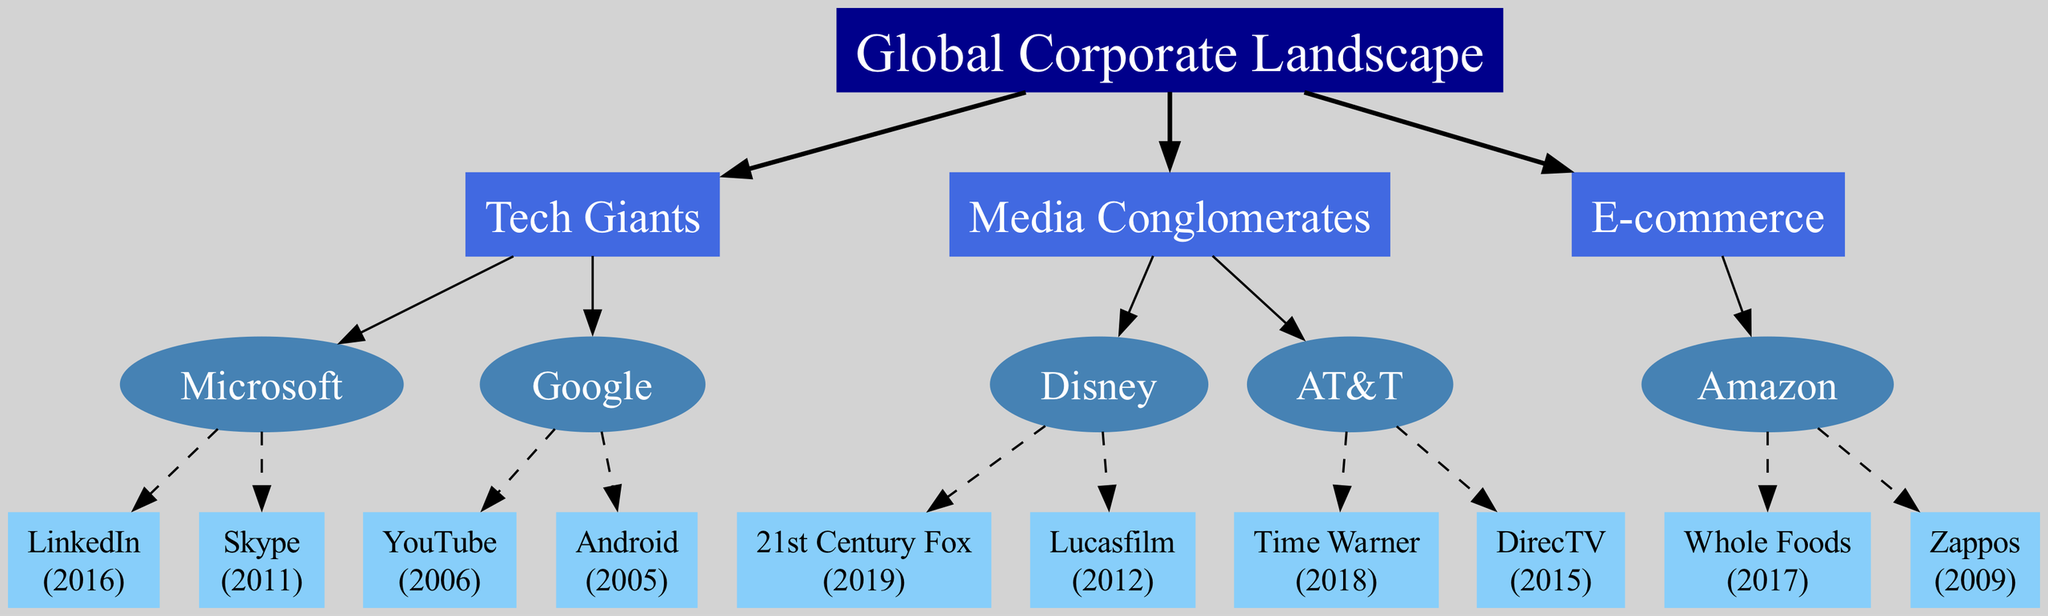What is the root of the family tree? The root of the family tree is the starting point, which denotes the overall theme of the diagram. Based on the data provided, it identifies the broad category encapsulating all companies and their acquisitions. Therefore, the root is "Global Corporate Landscape."
Answer: Global Corporate Landscape How many branches are there in the family tree? The branches of the family tree represent the major categories of companies involved in mergers and acquisitions. Counting the distinct branches listed in the data shows there are three branches: Tech Giants, Media Conglomerates, and E-commerce.
Answer: 3 Which company acquired LinkedIn? To find the company that acquired LinkedIn, we examine the acquisitions listed under the "Tech Giants" branch. LinkedIn is specifically noted as an acquisition of Microsoft in 2016.
Answer: Microsoft How many acquisitions did Disney make? This requires identifying the total number of acquisitions listed under Disney in the diagram. The data indicates that Disney has made two acquisitions: 21st Century Fox (2019) and Lucasfilm (2012). Therefore, the count of acquisitions is two.
Answer: 2 Which company has the latest acquisition, and what is it? To answer this, we evaluate the years of acquisitions within the diagram across all companies. The most recent acquisition listed is by Disney, which acquired 21st Century Fox in 2019.
Answer: Disney, 21st Century Fox What is the relationship between Google and Android? The relationship can be understood by examining the paths in the family tree structure. Google is a parent company under the "Tech Giants" branch, and Android is noted as its acquisition in 2005, illustrating a direct acquisition relationship.
Answer: Google acquired Android Which company under Media Conglomerates acquired Time Warner? Looking at the "Media Conglomerates" branch, we can identify that AT&T is the company listed that made the acquisition of Time Warner in 2018.
Answer: AT&T What type of company is Amazon categorized under in the diagram? The diagram categorizes Amazon as part of the "E-commerce" branch. This shows its relevance and positioning within the broader corporate landscape depicted in the family tree.
Answer: E-commerce How many total acquisitions are shown in the family tree? To get the total number of acquisitions, we list all unique acquisitions from each company mentioned in the branches: Microsoft (2), Google (2), Disney (2), AT&T (2), and Amazon (2). Adding these together results in a total of 12 acquisitions.
Answer: 12 